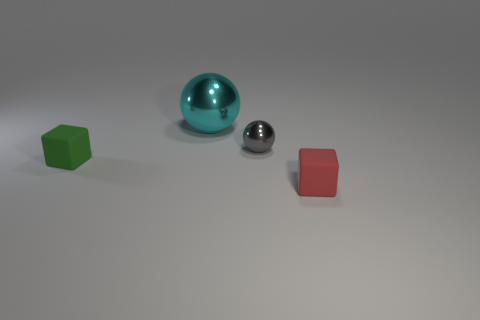Add 1 big spheres. How many objects exist? 5 Subtract 0 green cylinders. How many objects are left? 4 Subtract all blue things. Subtract all cyan metallic spheres. How many objects are left? 3 Add 1 green objects. How many green objects are left? 2 Add 1 small gray metal spheres. How many small gray metal spheres exist? 2 